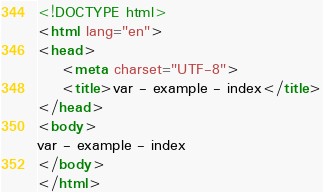Convert code to text. <code><loc_0><loc_0><loc_500><loc_500><_HTML_><!DOCTYPE html>
<html lang="en">
<head>
	<meta charset="UTF-8">
	<title>var - example - index</title>
</head>
<body>
var - example - index
</body>
</html></code> 